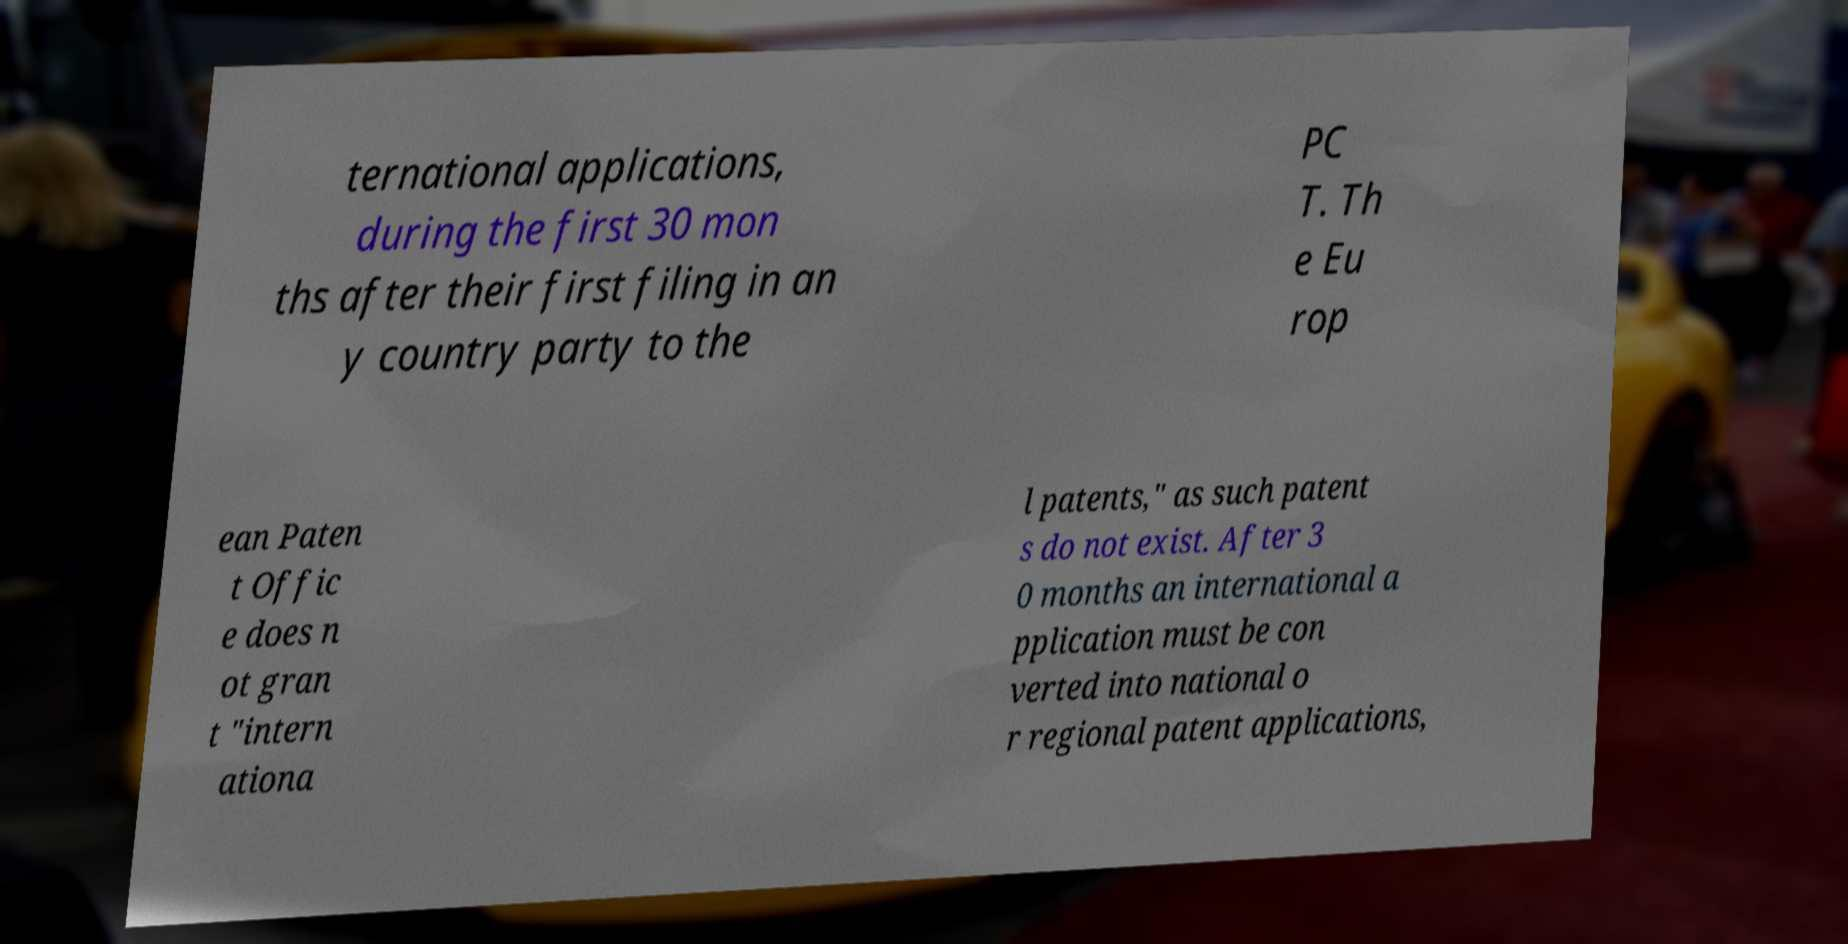Please read and relay the text visible in this image. What does it say? ternational applications, during the first 30 mon ths after their first filing in an y country party to the PC T. Th e Eu rop ean Paten t Offic e does n ot gran t "intern ationa l patents," as such patent s do not exist. After 3 0 months an international a pplication must be con verted into national o r regional patent applications, 